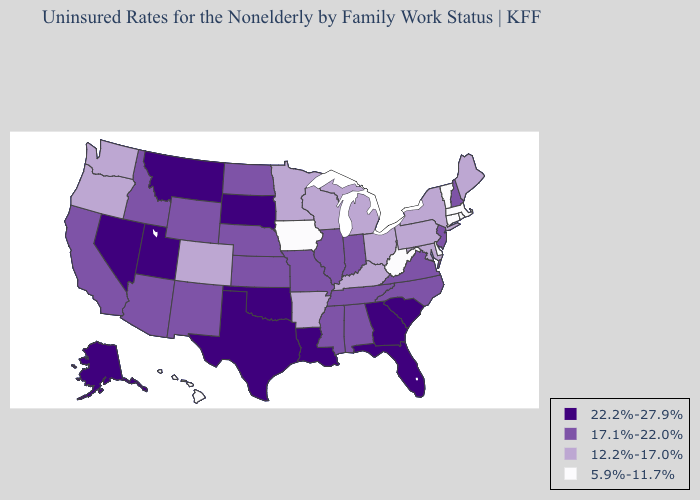What is the value of Texas?
Keep it brief. 22.2%-27.9%. Name the states that have a value in the range 22.2%-27.9%?
Short answer required. Alaska, Florida, Georgia, Louisiana, Montana, Nevada, Oklahoma, South Carolina, South Dakota, Texas, Utah. Does Iowa have a lower value than Washington?
Write a very short answer. Yes. What is the highest value in states that border Indiana?
Concise answer only. 17.1%-22.0%. Does Delaware have the lowest value in the USA?
Keep it brief. Yes. What is the highest value in the USA?
Short answer required. 22.2%-27.9%. What is the value of Delaware?
Be succinct. 5.9%-11.7%. Name the states that have a value in the range 22.2%-27.9%?
Answer briefly. Alaska, Florida, Georgia, Louisiana, Montana, Nevada, Oklahoma, South Carolina, South Dakota, Texas, Utah. What is the value of Alabama?
Concise answer only. 17.1%-22.0%. Does Nebraska have a higher value than Alabama?
Quick response, please. No. What is the value of South Dakota?
Give a very brief answer. 22.2%-27.9%. Name the states that have a value in the range 5.9%-11.7%?
Give a very brief answer. Connecticut, Delaware, Hawaii, Iowa, Massachusetts, Rhode Island, Vermont, West Virginia. What is the lowest value in states that border Connecticut?
Quick response, please. 5.9%-11.7%. Name the states that have a value in the range 17.1%-22.0%?
Quick response, please. Alabama, Arizona, California, Idaho, Illinois, Indiana, Kansas, Mississippi, Missouri, Nebraska, New Hampshire, New Jersey, New Mexico, North Carolina, North Dakota, Tennessee, Virginia, Wyoming. What is the lowest value in the MidWest?
Give a very brief answer. 5.9%-11.7%. 